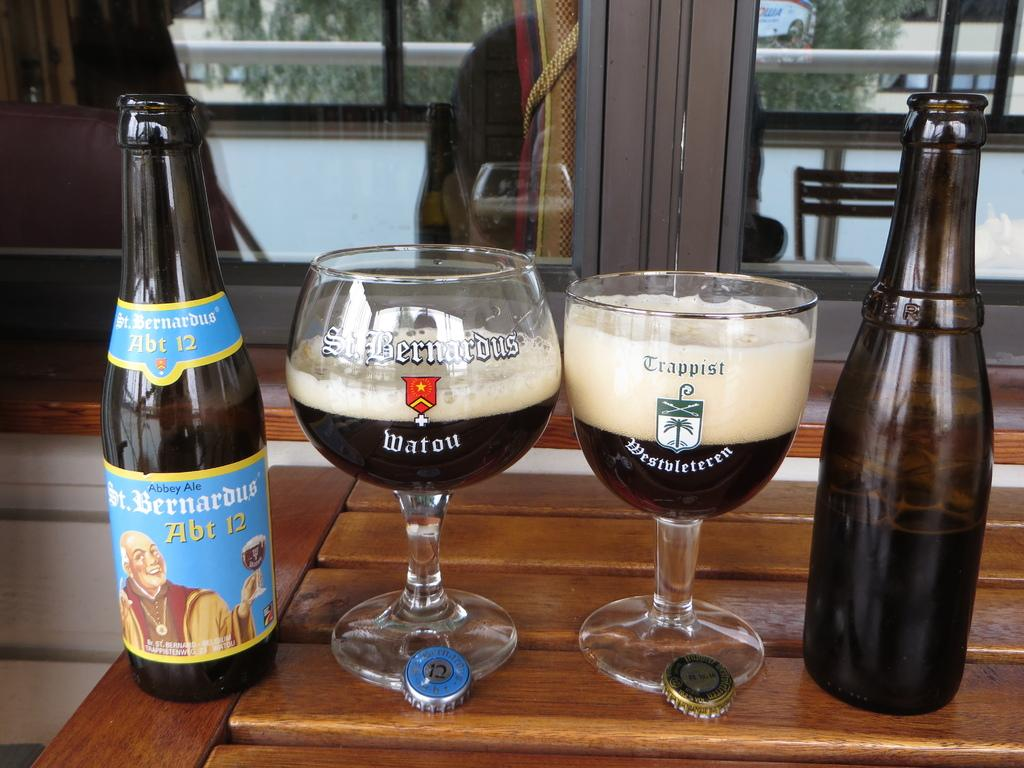What can be seen in the image that provides a view of the outdoors? There is a window in the image that provides a view of the outdoors. What piece of furniture is present in the image? There is a table in the image. What items are on the table in the image? There are glasses and bottles on the table in the image. What actor is delivering a caption in the image? There is no actor or caption present in the image. How many cakes are visible on the table in the image? There are no cakes visible on the table in the image. 